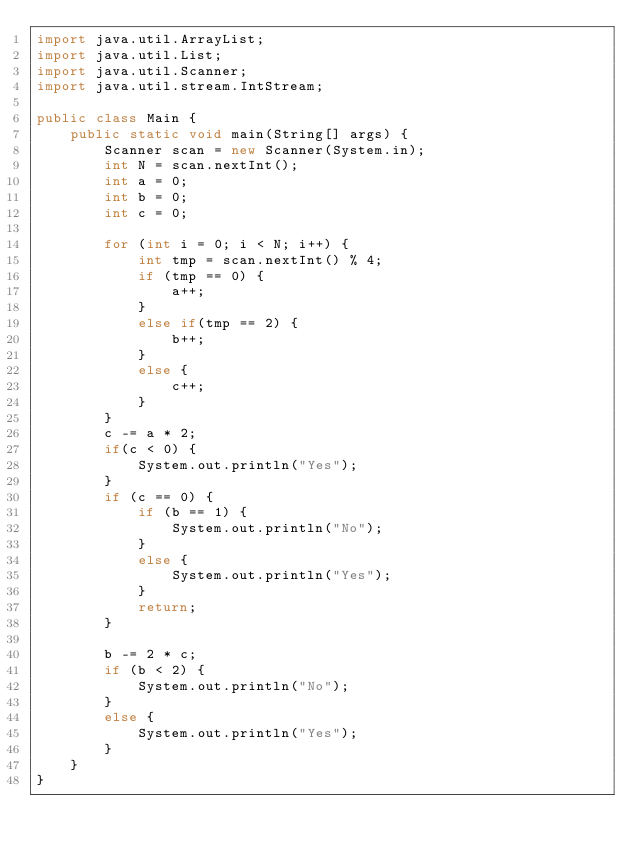Convert code to text. <code><loc_0><loc_0><loc_500><loc_500><_Java_>import java.util.ArrayList;
import java.util.List;
import java.util.Scanner;
import java.util.stream.IntStream;

public class Main {
    public static void main(String[] args) {
        Scanner scan = new Scanner(System.in);
        int N = scan.nextInt();
        int a = 0;
        int b = 0;
        int c = 0;

        for (int i = 0; i < N; i++) {
            int tmp = scan.nextInt() % 4;
            if (tmp == 0) {
                a++;
            }
            else if(tmp == 2) {
                b++;
            }
            else {
                c++;
            }
        }
        c -= a * 2;
        if(c < 0) {
            System.out.println("Yes");
        }
        if (c == 0) {
            if (b == 1) {
                System.out.println("No");
            }
            else {
                System.out.println("Yes");
            }
            return;
        }

        b -= 2 * c;
        if (b < 2) {
            System.out.println("No");
        }
        else {
            System.out.println("Yes");
        }
    }
}
</code> 